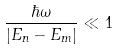<formula> <loc_0><loc_0><loc_500><loc_500>\frac { \hbar { \omega } } { | E _ { n } - E _ { m } | } \ll 1</formula> 